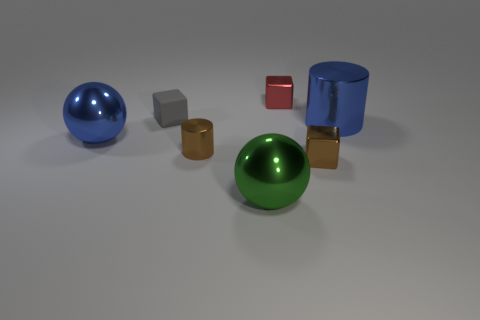Add 3 tiny red metallic cubes. How many objects exist? 10 Subtract all cubes. How many objects are left? 4 Add 4 small gray things. How many small gray things exist? 5 Subtract 1 green balls. How many objects are left? 6 Subtract all gray rubber things. Subtract all small metallic cubes. How many objects are left? 4 Add 6 blue objects. How many blue objects are left? 8 